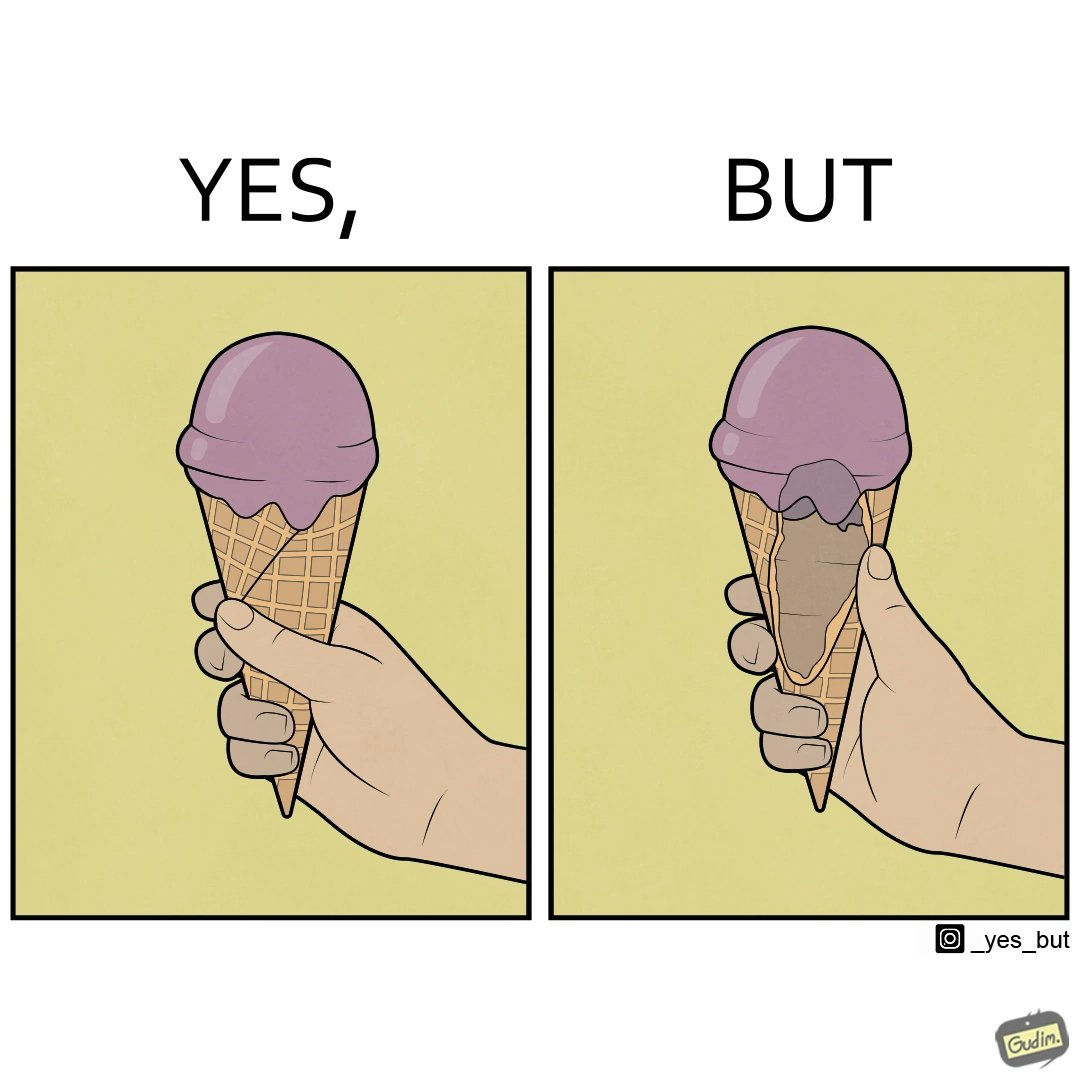What is shown in this image? The image is ironic, because in one image the softy cone is shown filled with softy but in second image it is visible that only the top of the cone is filled and at the inside the cone is vacant 